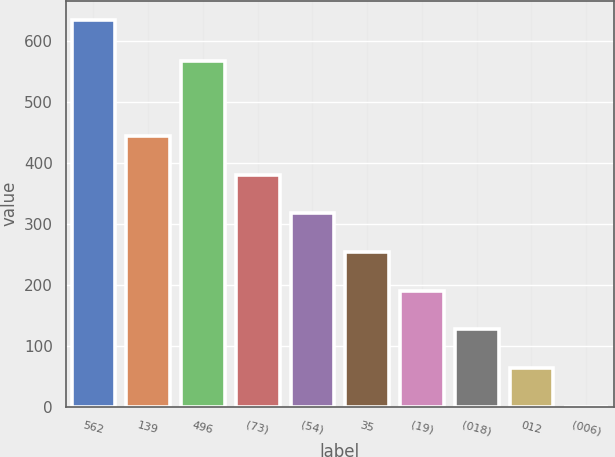<chart> <loc_0><loc_0><loc_500><loc_500><bar_chart><fcel>562<fcel>139<fcel>496<fcel>(73)<fcel>(54)<fcel>35<fcel>(19)<fcel>(018)<fcel>012<fcel>(006)<nl><fcel>634<fcel>443.85<fcel>567<fcel>380.45<fcel>317.05<fcel>253.65<fcel>190.25<fcel>126.85<fcel>63.45<fcel>0.05<nl></chart> 